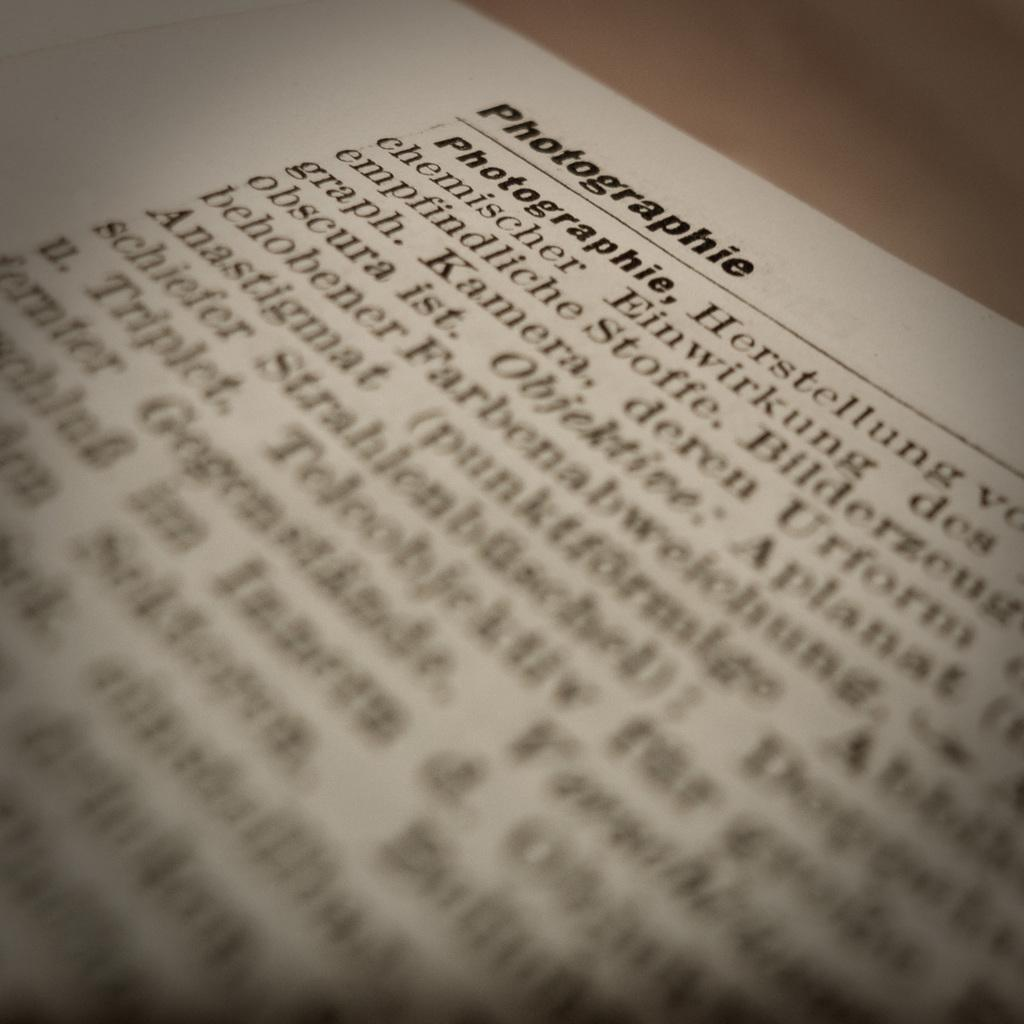<image>
Write a terse but informative summary of the picture. A book is open to a page about Photographie. 